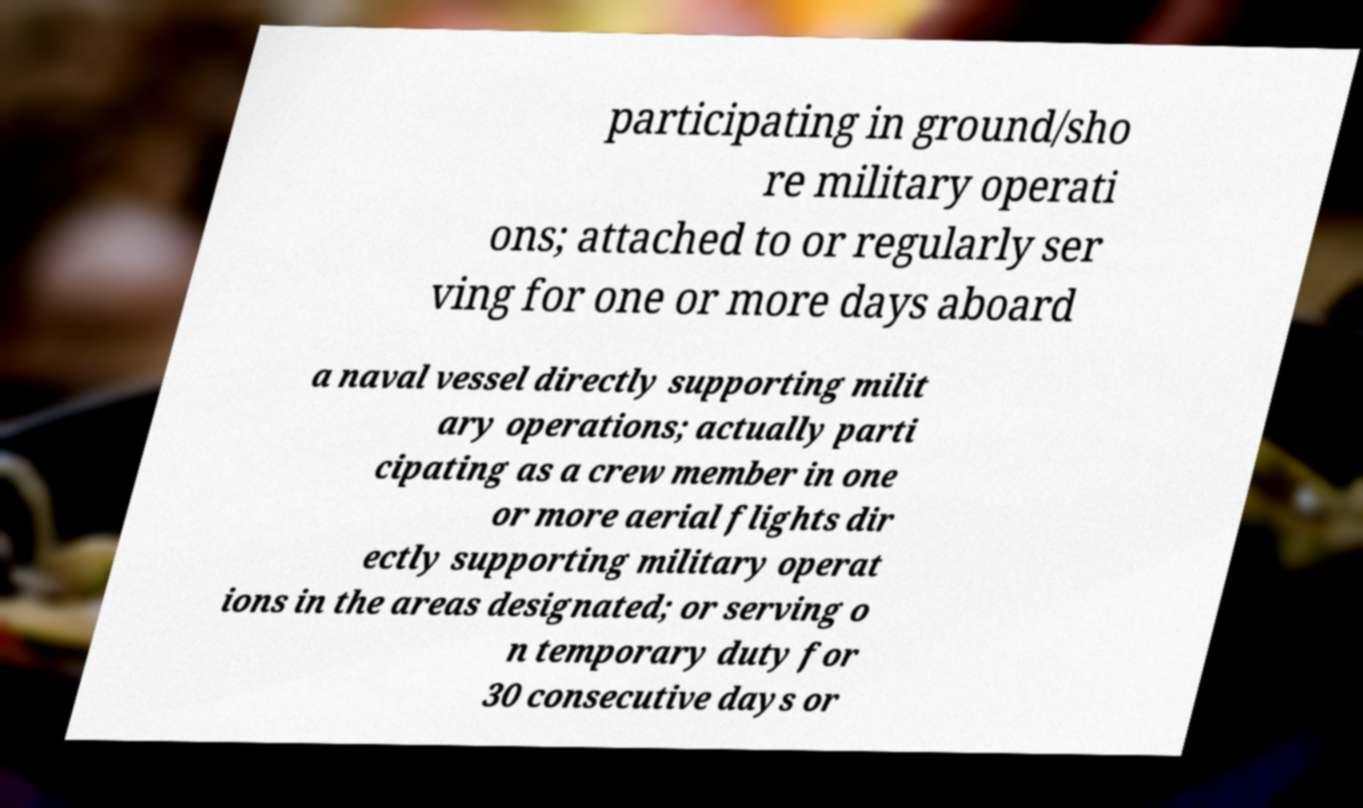Please identify and transcribe the text found in this image. participating in ground/sho re military operati ons; attached to or regularly ser ving for one or more days aboard a naval vessel directly supporting milit ary operations; actually parti cipating as a crew member in one or more aerial flights dir ectly supporting military operat ions in the areas designated; or serving o n temporary duty for 30 consecutive days or 